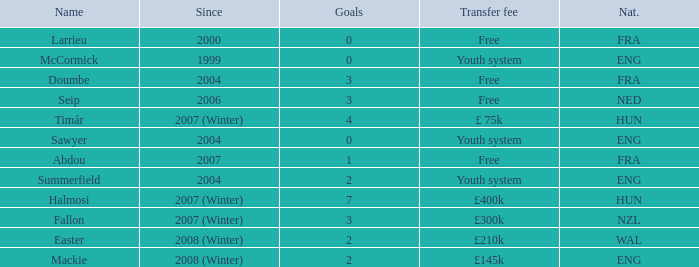What the since year of the player with a transfer fee of £ 75k? 2007 (Winter). 